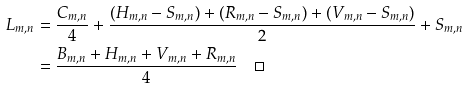Convert formula to latex. <formula><loc_0><loc_0><loc_500><loc_500>L _ { m , n } & = \frac { C _ { m , n } } { 4 } + \frac { ( H _ { m , n } - S _ { m , n } ) + ( R _ { m , n } - S _ { m , n } ) + ( V _ { m , n } - S _ { m , n } ) } { 2 } + S _ { m , n } \\ & = \frac { B _ { m , n } + H _ { m , n } + V _ { m , n } + R _ { m , n } } { 4 } \quad \Box</formula> 